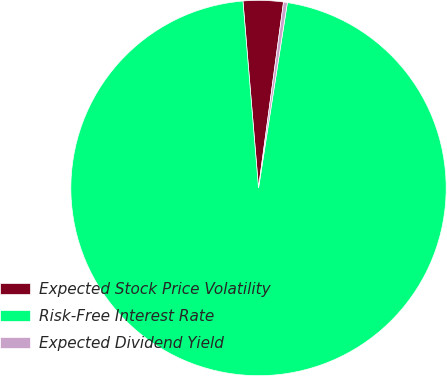Convert chart to OTSL. <chart><loc_0><loc_0><loc_500><loc_500><pie_chart><fcel>Expected Stock Price Volatility<fcel>Risk-Free Interest Rate<fcel>Expected Dividend Yield<nl><fcel>3.45%<fcel>96.22%<fcel>0.33%<nl></chart> 